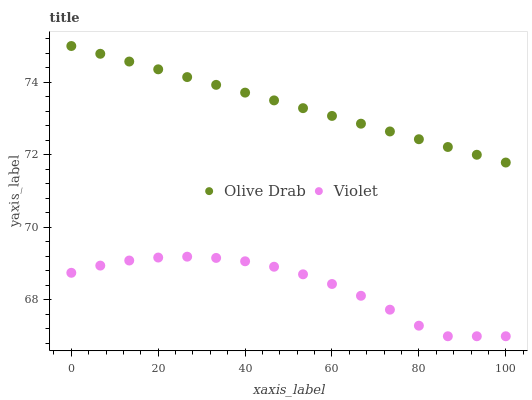Does Violet have the minimum area under the curve?
Answer yes or no. Yes. Does Olive Drab have the maximum area under the curve?
Answer yes or no. Yes. Does Violet have the maximum area under the curve?
Answer yes or no. No. Is Olive Drab the smoothest?
Answer yes or no. Yes. Is Violet the roughest?
Answer yes or no. Yes. Is Violet the smoothest?
Answer yes or no. No. Does Violet have the lowest value?
Answer yes or no. Yes. Does Olive Drab have the highest value?
Answer yes or no. Yes. Does Violet have the highest value?
Answer yes or no. No. Is Violet less than Olive Drab?
Answer yes or no. Yes. Is Olive Drab greater than Violet?
Answer yes or no. Yes. Does Violet intersect Olive Drab?
Answer yes or no. No. 